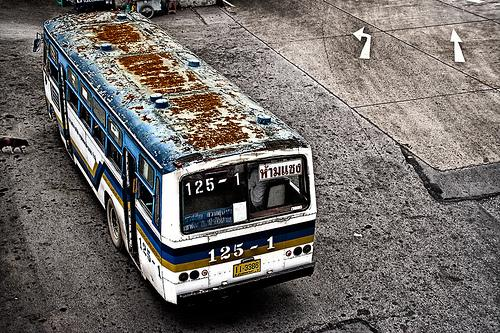What work does this bus need to have done on it? cleaning 